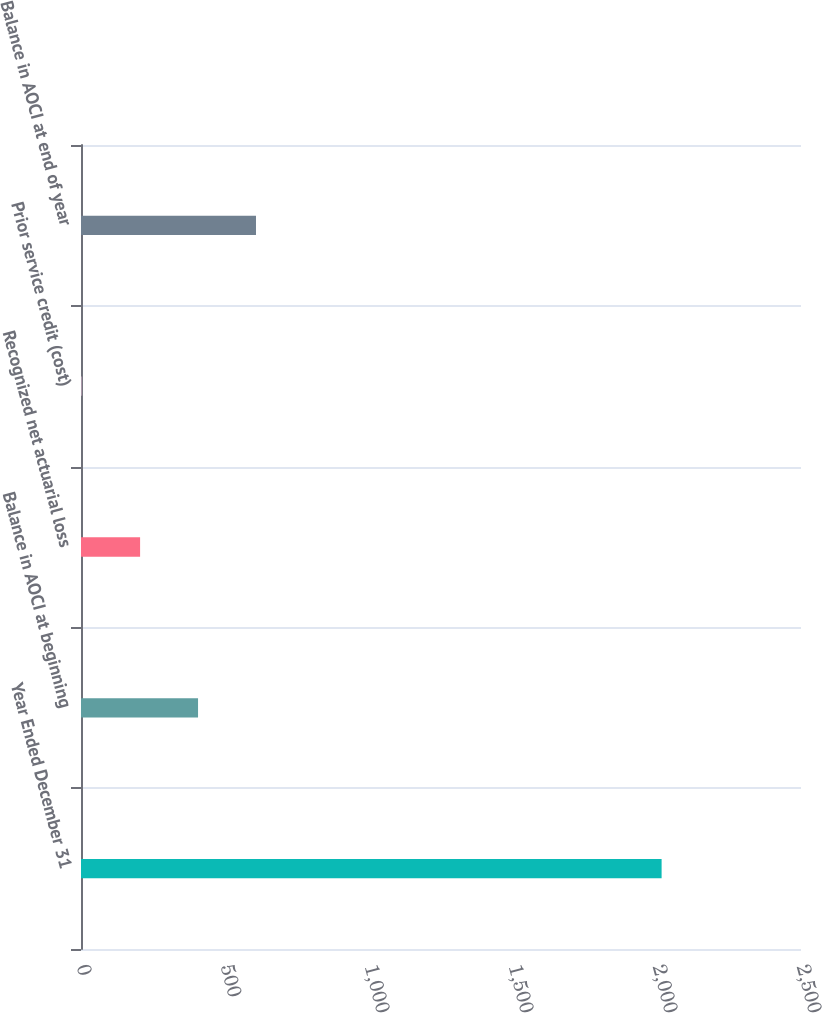Convert chart to OTSL. <chart><loc_0><loc_0><loc_500><loc_500><bar_chart><fcel>Year Ended December 31<fcel>Balance in AOCI at beginning<fcel>Recognized net actuarial loss<fcel>Prior service credit (cost)<fcel>Balance in AOCI at end of year<nl><fcel>2016<fcel>406.4<fcel>205.2<fcel>4<fcel>607.6<nl></chart> 